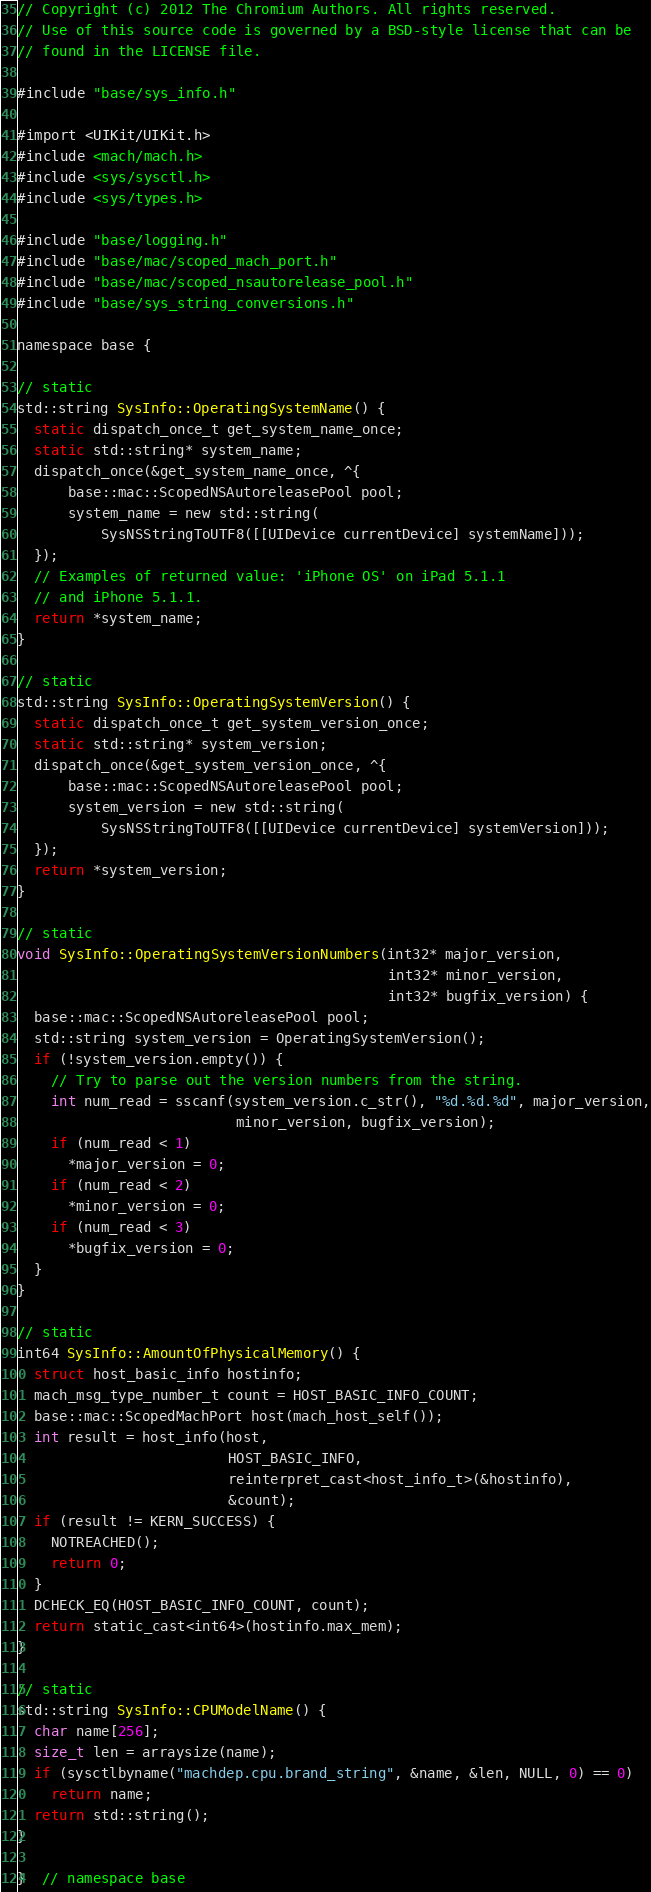<code> <loc_0><loc_0><loc_500><loc_500><_ObjectiveC_>// Copyright (c) 2012 The Chromium Authors. All rights reserved.
// Use of this source code is governed by a BSD-style license that can be
// found in the LICENSE file.

#include "base/sys_info.h"

#import <UIKit/UIKit.h>
#include <mach/mach.h>
#include <sys/sysctl.h>
#include <sys/types.h>

#include "base/logging.h"
#include "base/mac/scoped_mach_port.h"
#include "base/mac/scoped_nsautorelease_pool.h"
#include "base/sys_string_conversions.h"

namespace base {

// static
std::string SysInfo::OperatingSystemName() {
  static dispatch_once_t get_system_name_once;
  static std::string* system_name;
  dispatch_once(&get_system_name_once, ^{
      base::mac::ScopedNSAutoreleasePool pool;
      system_name = new std::string(
          SysNSStringToUTF8([[UIDevice currentDevice] systemName]));
  });
  // Examples of returned value: 'iPhone OS' on iPad 5.1.1
  // and iPhone 5.1.1.
  return *system_name;
}

// static
std::string SysInfo::OperatingSystemVersion() {
  static dispatch_once_t get_system_version_once;
  static std::string* system_version;
  dispatch_once(&get_system_version_once, ^{
      base::mac::ScopedNSAutoreleasePool pool;
      system_version = new std::string(
          SysNSStringToUTF8([[UIDevice currentDevice] systemVersion]));
  });
  return *system_version;
}

// static
void SysInfo::OperatingSystemVersionNumbers(int32* major_version,
                                            int32* minor_version,
                                            int32* bugfix_version) {
  base::mac::ScopedNSAutoreleasePool pool;
  std::string system_version = OperatingSystemVersion();
  if (!system_version.empty()) {
    // Try to parse out the version numbers from the string.
    int num_read = sscanf(system_version.c_str(), "%d.%d.%d", major_version,
                          minor_version, bugfix_version);
    if (num_read < 1)
      *major_version = 0;
    if (num_read < 2)
      *minor_version = 0;
    if (num_read < 3)
      *bugfix_version = 0;
  }
}

// static
int64 SysInfo::AmountOfPhysicalMemory() {
  struct host_basic_info hostinfo;
  mach_msg_type_number_t count = HOST_BASIC_INFO_COUNT;
  base::mac::ScopedMachPort host(mach_host_self());
  int result = host_info(host,
                         HOST_BASIC_INFO,
                         reinterpret_cast<host_info_t>(&hostinfo),
                         &count);
  if (result != KERN_SUCCESS) {
    NOTREACHED();
    return 0;
  }
  DCHECK_EQ(HOST_BASIC_INFO_COUNT, count);
  return static_cast<int64>(hostinfo.max_mem);
}

// static
std::string SysInfo::CPUModelName() {
  char name[256];
  size_t len = arraysize(name);
  if (sysctlbyname("machdep.cpu.brand_string", &name, &len, NULL, 0) == 0)
    return name;
  return std::string();
}

}  // namespace base
</code> 